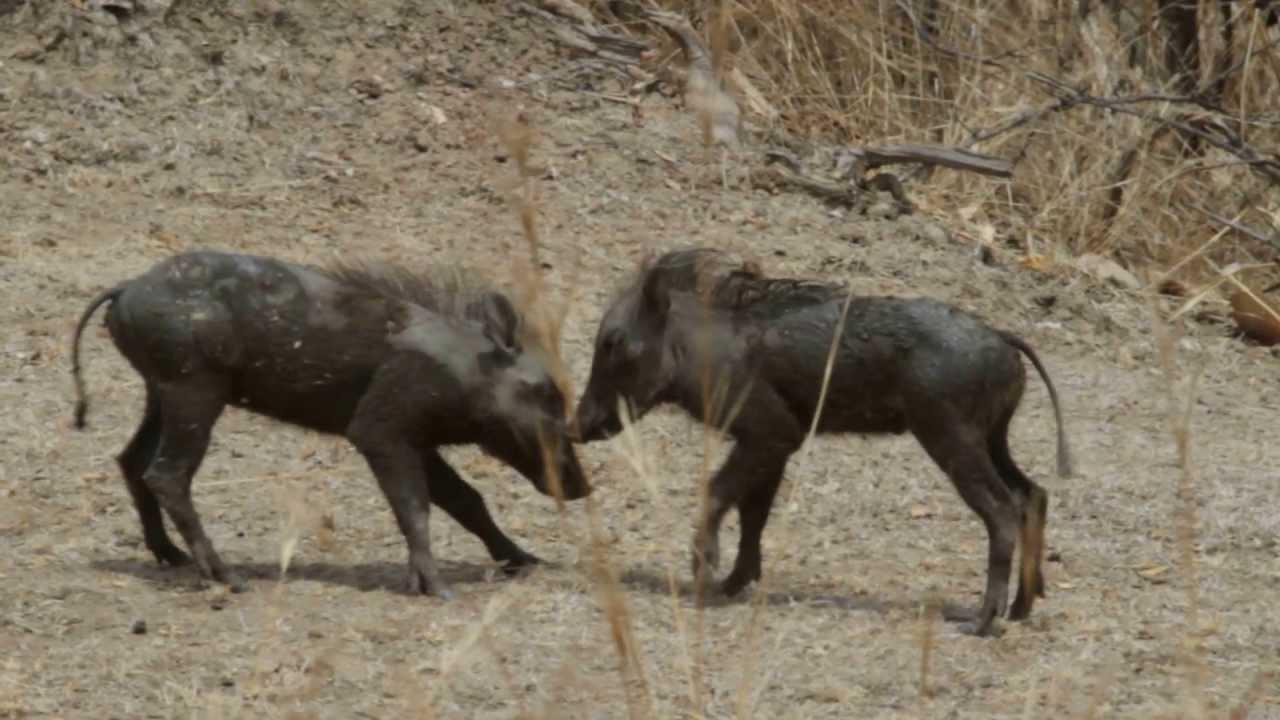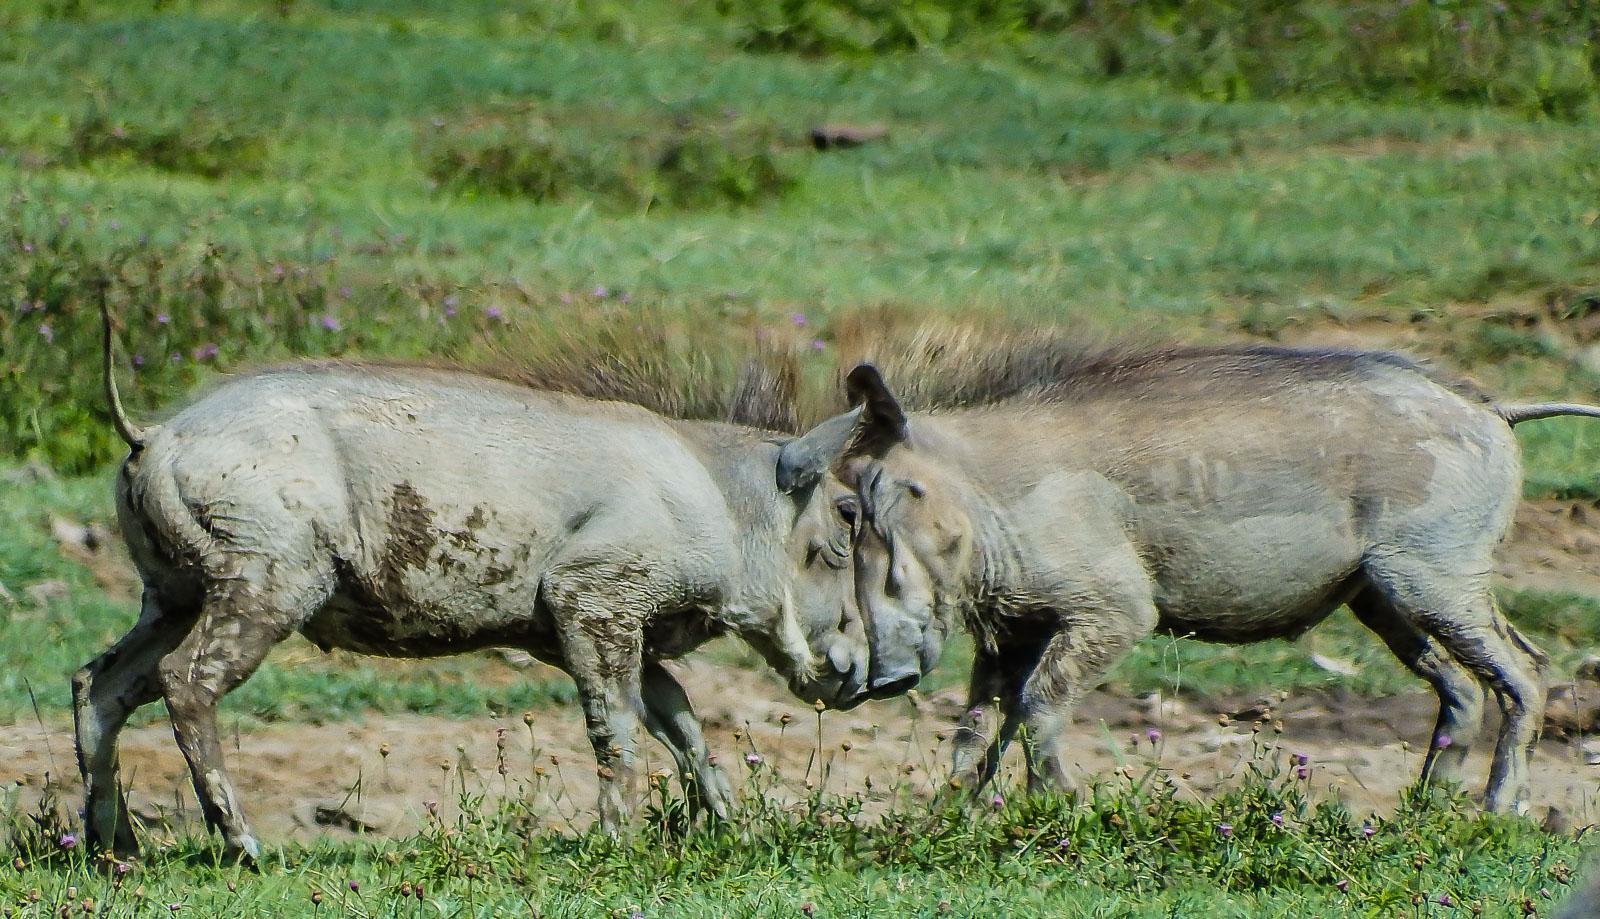The first image is the image on the left, the second image is the image on the right. Given the left and right images, does the statement "There are two pairs of warthogs standing with their faces touching." hold true? Answer yes or no. Yes. The first image is the image on the left, the second image is the image on the right. Evaluate the accuracy of this statement regarding the images: "Both images show a pair of warthogs posed face-to-face.". Is it true? Answer yes or no. Yes. 